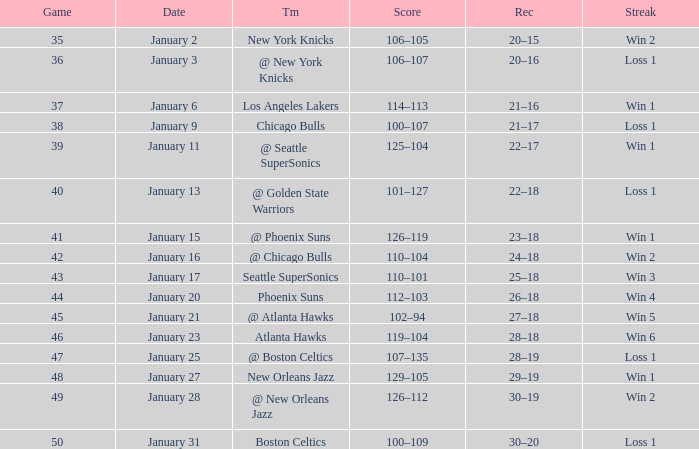What is the Team on January 20? Phoenix Suns. 